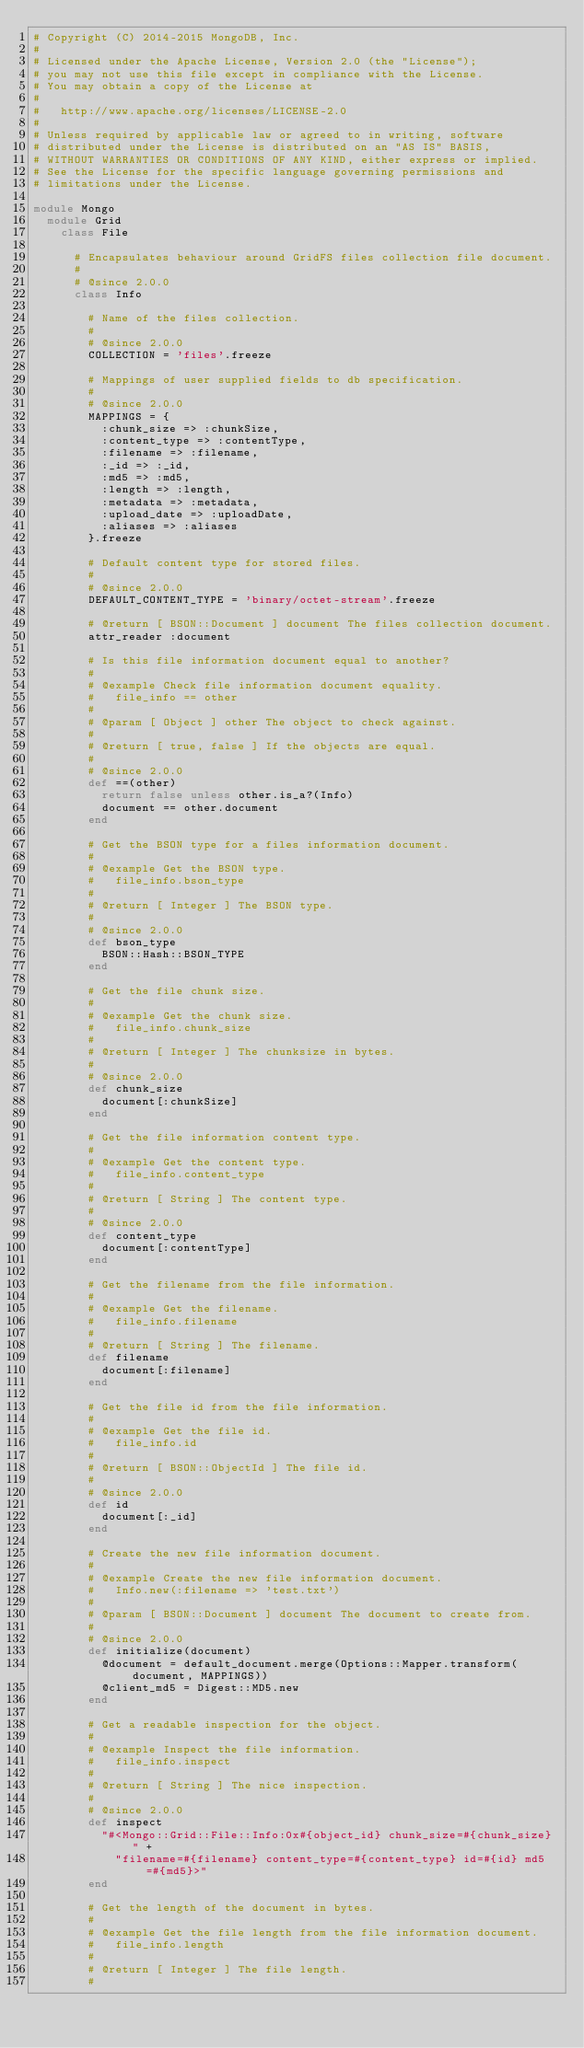Convert code to text. <code><loc_0><loc_0><loc_500><loc_500><_Ruby_># Copyright (C) 2014-2015 MongoDB, Inc.
#
# Licensed under the Apache License, Version 2.0 (the "License");
# you may not use this file except in compliance with the License.
# You may obtain a copy of the License at
#
#   http://www.apache.org/licenses/LICENSE-2.0
#
# Unless required by applicable law or agreed to in writing, software
# distributed under the License is distributed on an "AS IS" BASIS,
# WITHOUT WARRANTIES OR CONDITIONS OF ANY KIND, either express or implied.
# See the License for the specific language governing permissions and
# limitations under the License.

module Mongo
  module Grid
    class File

      # Encapsulates behaviour around GridFS files collection file document.
      #
      # @since 2.0.0
      class Info

        # Name of the files collection.
        #
        # @since 2.0.0
        COLLECTION = 'files'.freeze

        # Mappings of user supplied fields to db specification.
        #
        # @since 2.0.0
        MAPPINGS = {
          :chunk_size => :chunkSize,
          :content_type => :contentType,
          :filename => :filename,
          :_id => :_id,
          :md5 => :md5,
          :length => :length,
          :metadata => :metadata,
          :upload_date => :uploadDate,
          :aliases => :aliases
        }.freeze

        # Default content type for stored files.
        #
        # @since 2.0.0
        DEFAULT_CONTENT_TYPE = 'binary/octet-stream'.freeze

        # @return [ BSON::Document ] document The files collection document.
        attr_reader :document

        # Is this file information document equal to another?
        #
        # @example Check file information document equality.
        #   file_info == other
        #
        # @param [ Object ] other The object to check against.
        #
        # @return [ true, false ] If the objects are equal.
        #
        # @since 2.0.0
        def ==(other)
          return false unless other.is_a?(Info)
          document == other.document
        end

        # Get the BSON type for a files information document.
        #
        # @example Get the BSON type.
        #   file_info.bson_type
        #
        # @return [ Integer ] The BSON type.
        #
        # @since 2.0.0
        def bson_type
          BSON::Hash::BSON_TYPE
        end

        # Get the file chunk size.
        #
        # @example Get the chunk size.
        #   file_info.chunk_size
        #
        # @return [ Integer ] The chunksize in bytes.
        #
        # @since 2.0.0
        def chunk_size
          document[:chunkSize]
        end

        # Get the file information content type.
        #
        # @example Get the content type.
        #   file_info.content_type
        #
        # @return [ String ] The content type.
        #
        # @since 2.0.0
        def content_type
          document[:contentType]
        end

        # Get the filename from the file information.
        #
        # @example Get the filename.
        #   file_info.filename
        #
        # @return [ String ] The filename.
        def filename
          document[:filename]
        end

        # Get the file id from the file information.
        #
        # @example Get the file id.
        #   file_info.id
        #
        # @return [ BSON::ObjectId ] The file id.
        #
        # @since 2.0.0
        def id
          document[:_id]
        end

        # Create the new file information document.
        #
        # @example Create the new file information document.
        #   Info.new(:filename => 'test.txt')
        #
        # @param [ BSON::Document ] document The document to create from.
        #
        # @since 2.0.0
        def initialize(document)
          @document = default_document.merge(Options::Mapper.transform(document, MAPPINGS))
          @client_md5 = Digest::MD5.new
        end

        # Get a readable inspection for the object.
        #
        # @example Inspect the file information.
        #   file_info.inspect
        #
        # @return [ String ] The nice inspection.
        #
        # @since 2.0.0
        def inspect
          "#<Mongo::Grid::File::Info:0x#{object_id} chunk_size=#{chunk_size} " +
            "filename=#{filename} content_type=#{content_type} id=#{id} md5=#{md5}>"
        end

        # Get the length of the document in bytes.
        #
        # @example Get the file length from the file information document.
        #   file_info.length
        #
        # @return [ Integer ] The file length.
        #</code> 